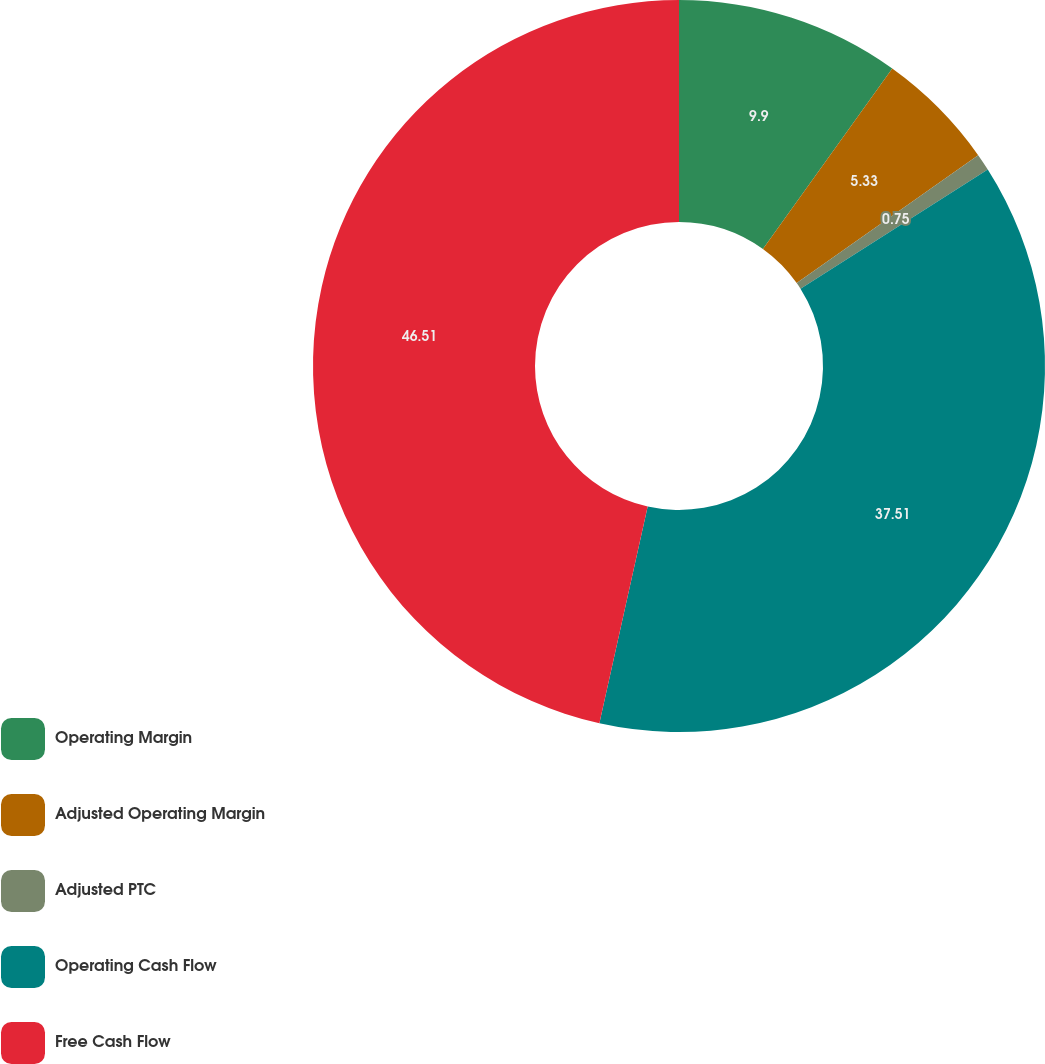<chart> <loc_0><loc_0><loc_500><loc_500><pie_chart><fcel>Operating Margin<fcel>Adjusted Operating Margin<fcel>Adjusted PTC<fcel>Operating Cash Flow<fcel>Free Cash Flow<nl><fcel>9.9%<fcel>5.33%<fcel>0.75%<fcel>37.51%<fcel>46.51%<nl></chart> 